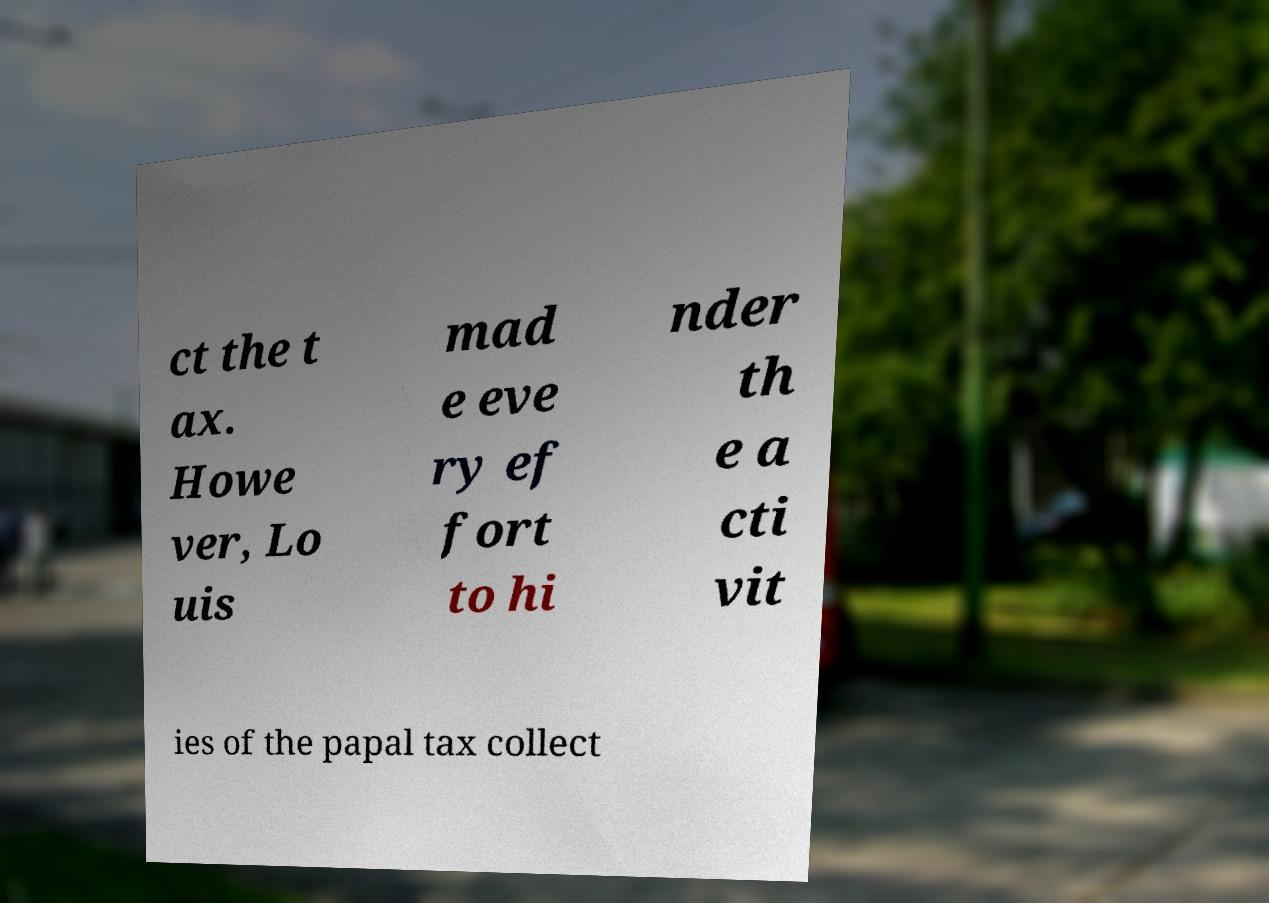Can you read and provide the text displayed in the image?This photo seems to have some interesting text. Can you extract and type it out for me? ct the t ax. Howe ver, Lo uis mad e eve ry ef fort to hi nder th e a cti vit ies of the papal tax collect 